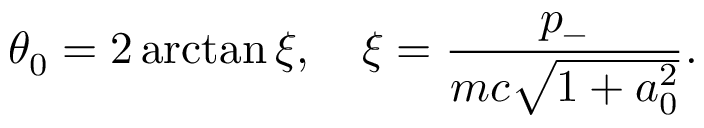Convert formula to latex. <formula><loc_0><loc_0><loc_500><loc_500>\theta _ { 0 } = 2 \arctan \xi , \quad \xi = \frac { p _ { - } } { m c \sqrt { 1 + a _ { 0 } ^ { 2 } } } .</formula> 